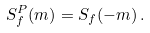<formula> <loc_0><loc_0><loc_500><loc_500>S _ { f } ^ { P } ( m ) = S _ { f } ( - m ) \, .</formula> 